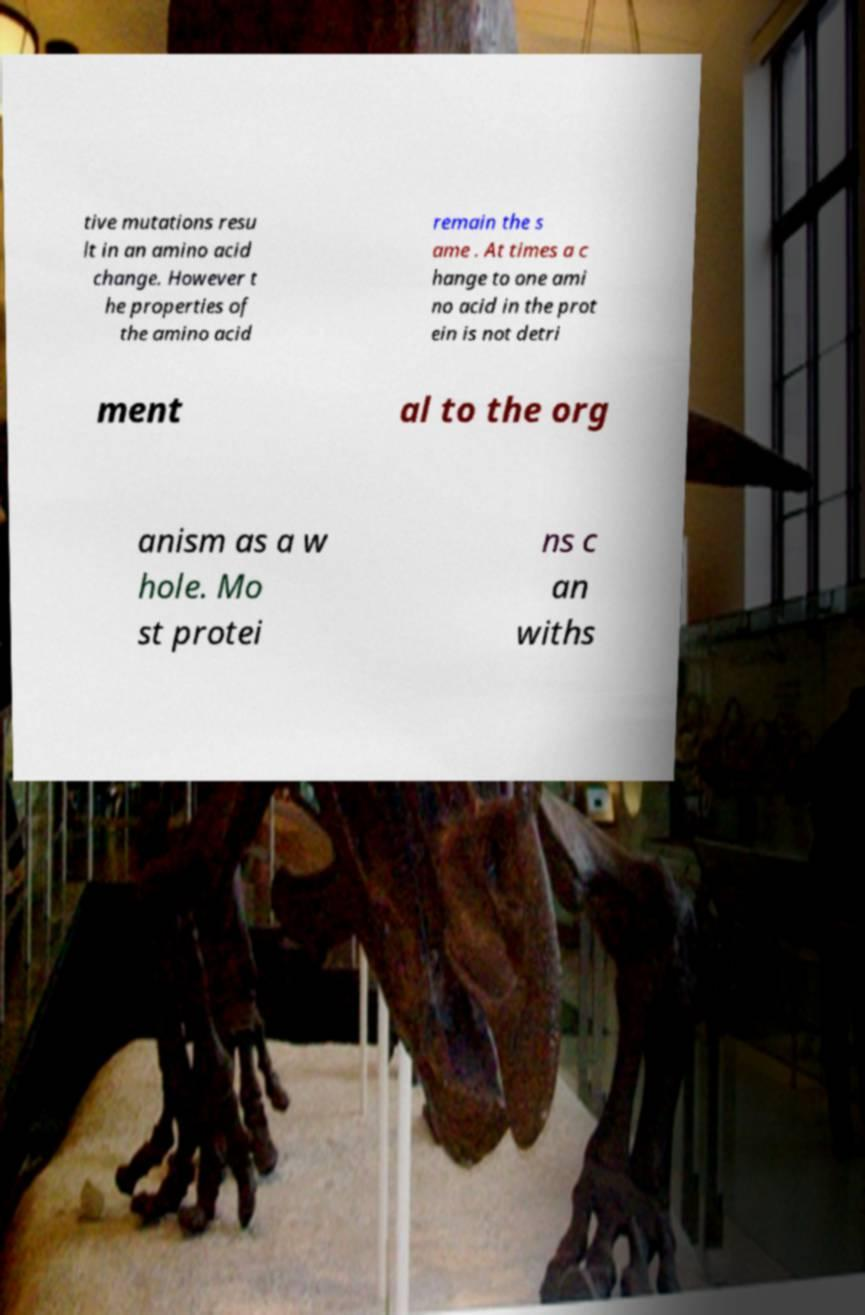Could you assist in decoding the text presented in this image and type it out clearly? tive mutations resu lt in an amino acid change. However t he properties of the amino acid remain the s ame . At times a c hange to one ami no acid in the prot ein is not detri ment al to the org anism as a w hole. Mo st protei ns c an withs 